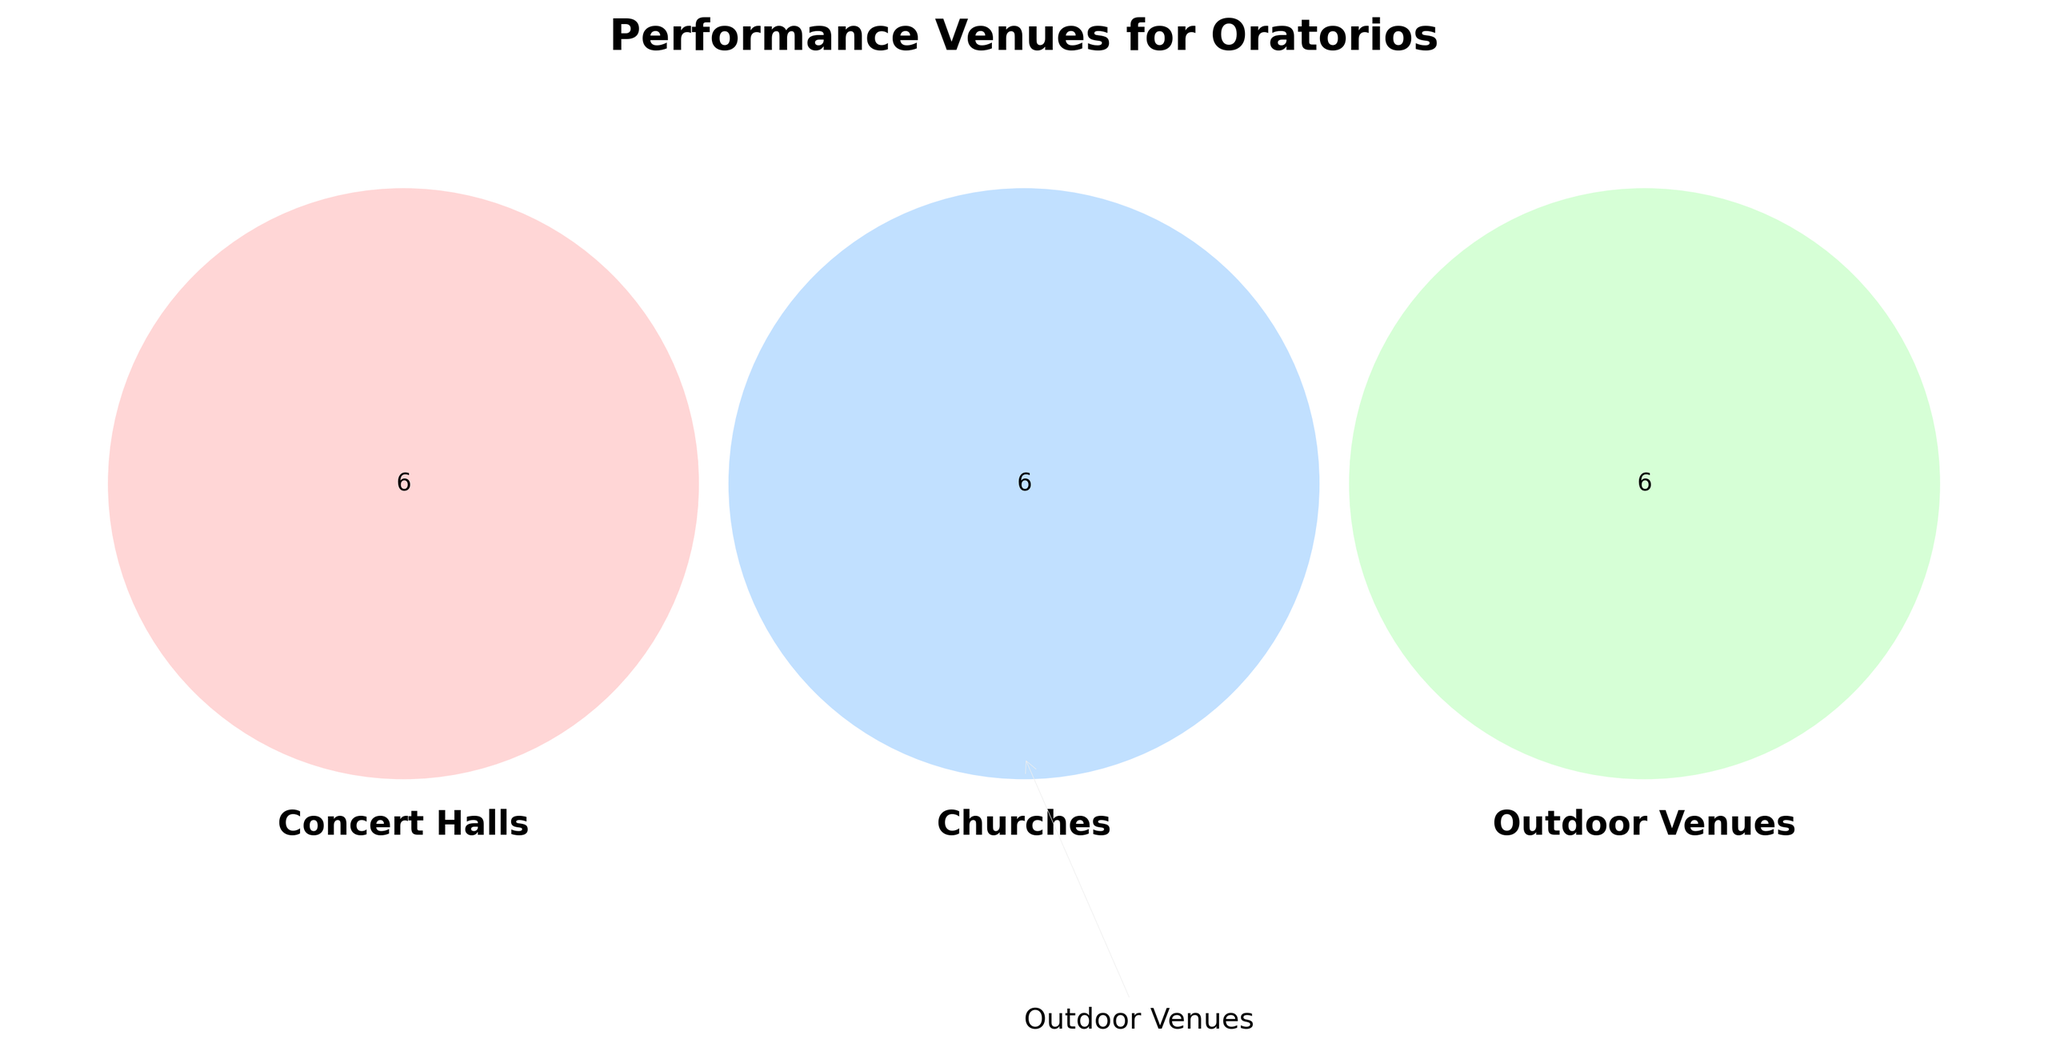Which type of performance venue is highlighted on the left side of the figure? The left side of the Venn Diagram is labeled with an arrow pointing to "Concert Halls."
Answer: Concert Halls What is the title of the figure? The title of the figure is placed above the Venn Diagram and clearly states the main focus.
Answer: Performance Venues for Oratorios Which performance venue type is represented by the circle on the bottom part of the figure? The bottom part of the Venn Diagram is labeled with an arrow indicating "Outdoor Venues."
Answer: Outdoor Venues How many distinct performance venues are listed for Churches? The Venn Diagram has a specific circle for Churches, each label inside it represents one venue. There are six venues listed.
Answer: Six Is the intersection between Concert Halls and Outdoor Venues empty? Look at the area where the circles for Concert Halls and Outdoor Venues overlap. If there are no venue names in that overlapping area, it's empty.
Answer: Yes How many unique performance venues are there in Outdoor Venues but not in Concert Halls or Churches? Check the section of the Outdoor Venues circle that does not intersect with the other two circles. Count the venue names listed in that section.
Answer: Six Which performance venue is common between all three types of venues? Identify the middle section where all three circles overlap and check for any venue names listed there.
Answer: None How many performance venues are unique to Churches but not intersected by Concert Halls or Outdoor Venues? Count the number of venue names in the section exclusive to Churches.
Answer: Six How many total performance venues are represented across all three categories in the figure? Sum the number of venues listed in each distinct and overlapping section of the Venn Diagram.
Answer: Eighteen 